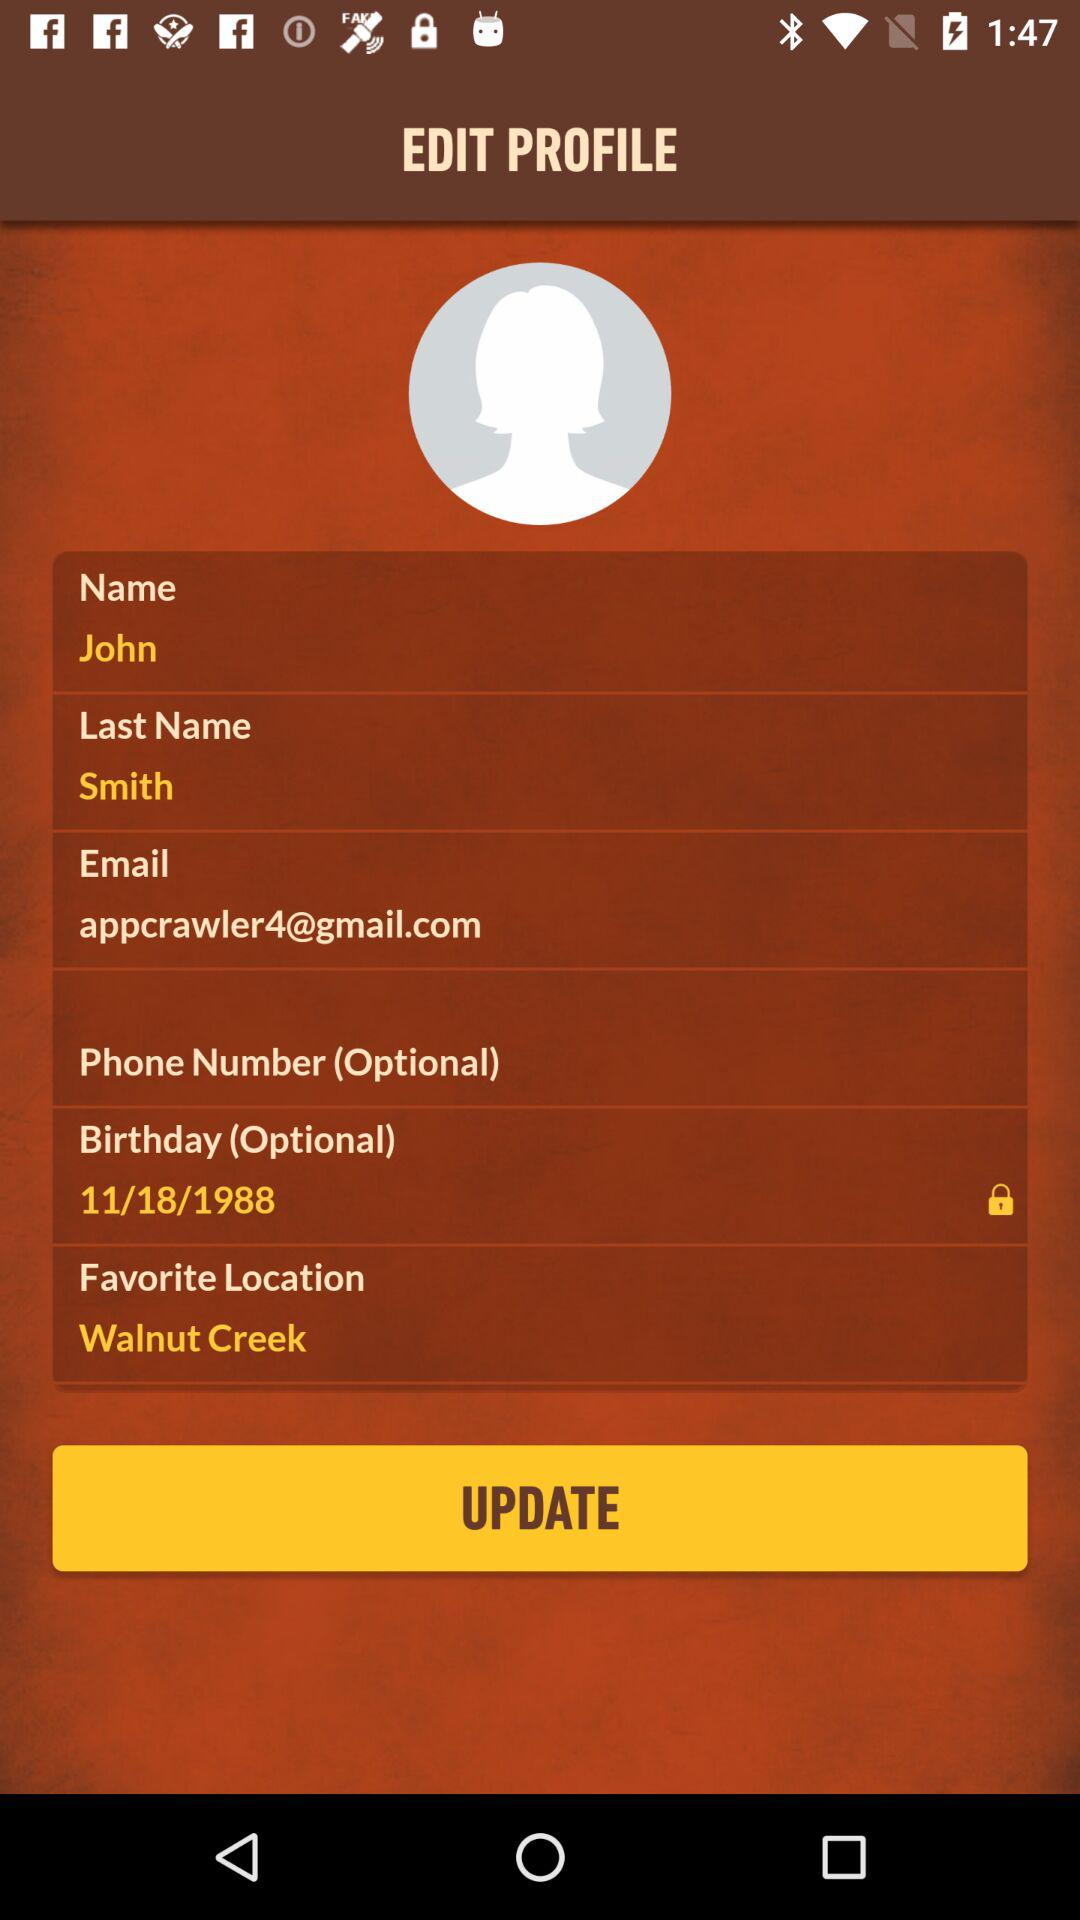What is the email address? The email address is appcrawler4@gmail.com. 